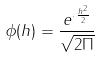<formula> <loc_0><loc_0><loc_500><loc_500>\phi ( h ) = \frac { e ^ { \cdot \frac { h ^ { 2 } } { 2 } } } { \sqrt { 2 \Pi } }</formula> 